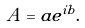Convert formula to latex. <formula><loc_0><loc_0><loc_500><loc_500>A = a e ^ { i b } .</formula> 